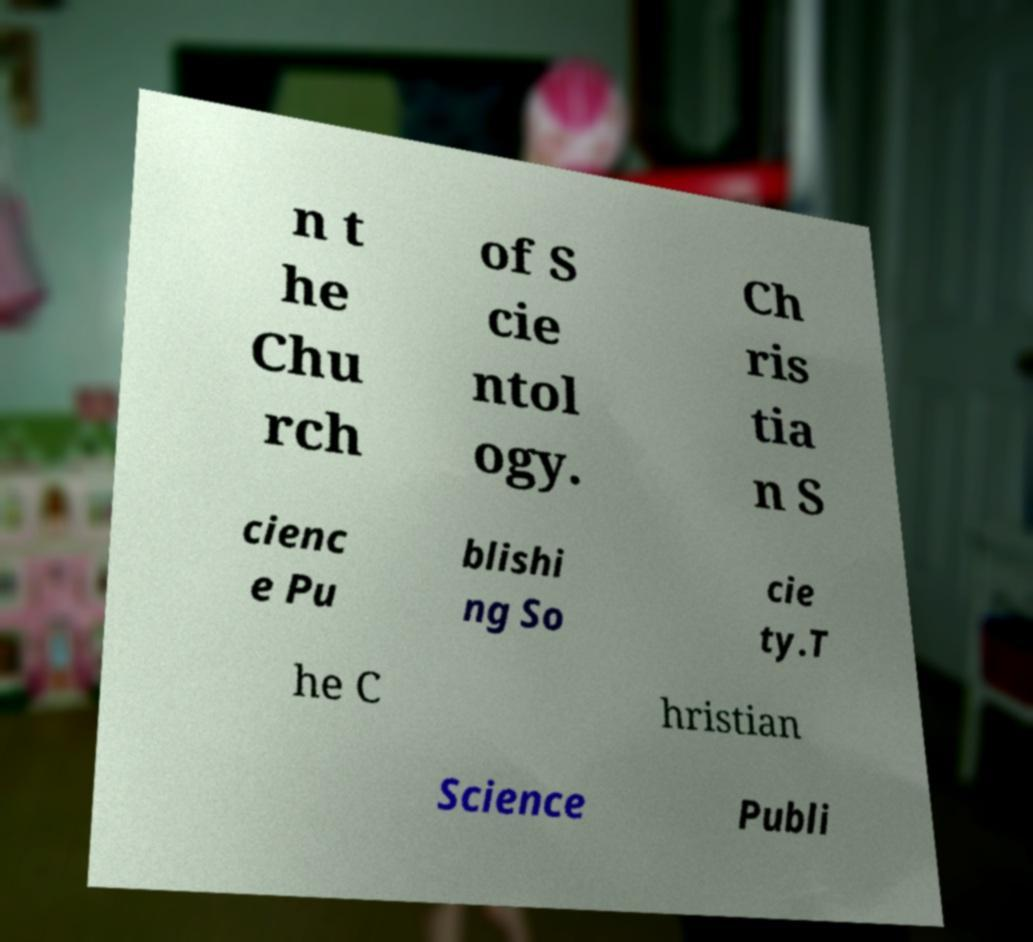Can you read and provide the text displayed in the image?This photo seems to have some interesting text. Can you extract and type it out for me? n t he Chu rch of S cie ntol ogy. Ch ris tia n S cienc e Pu blishi ng So cie ty.T he C hristian Science Publi 